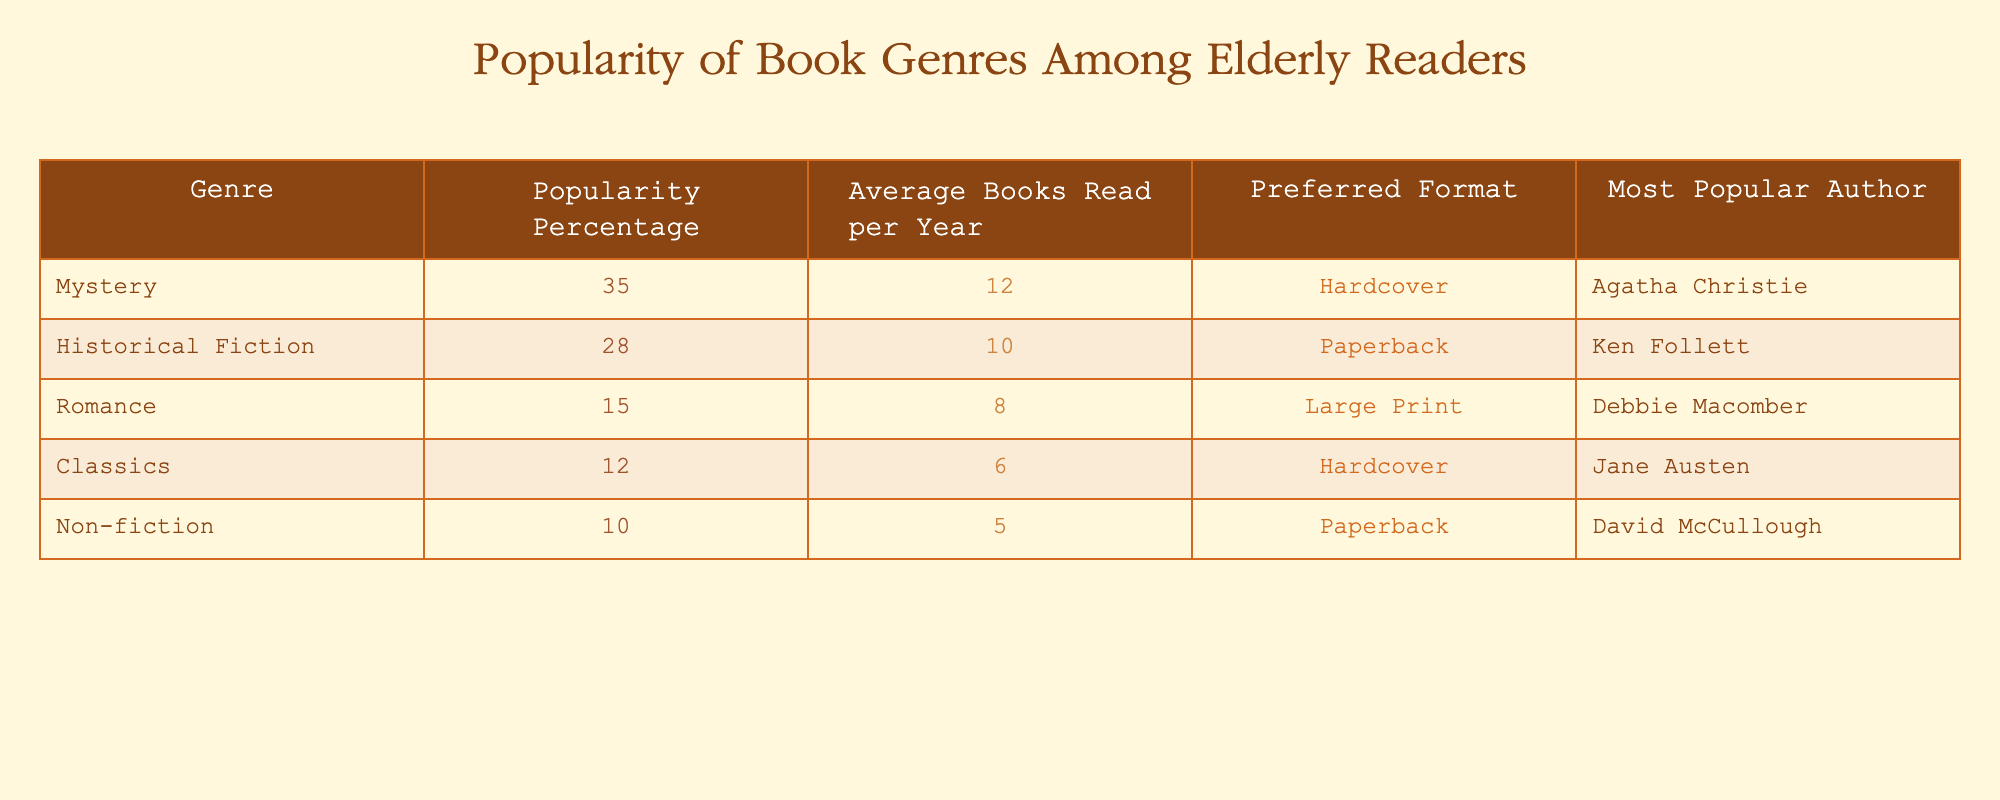What is the most popular book genre among elderly readers? The table shows that the genre with the highest popularity percentage is Mystery at 35%.
Answer: Mystery Which author is associated with the Historical Fiction genre? According to the table, the most popular author for Historical Fiction is Ken Follett.
Answer: Ken Follett How many average books does an elderly reader read in a year for the Romance genre? The table lists that elderly readers read an average of 8 books per year in the Romance genre.
Answer: 8 What percentage of elderly readers prefer Mystery over Non-fiction? The table indicates a popularity percentage of 35% for Mystery and 10% for Non-fiction. The difference is 35% - 10% = 25%.
Answer: 25% Is it true that the Classics genre has a higher popularity percentage than Non-fiction? The table shows that Classics has 12% popularity and Non-fiction has 10%. Since 12% is greater than 10%, the statement is true.
Answer: Yes If you add the average books read per year for Mystery and Historical Fiction, what do you get? The average books read per year for Mystery is 12 and for Historical Fiction is 10. Adding these together gives 12 + 10 = 22 books.
Answer: 22 Which genre has the least number of average books read per year? From the table, Non-fiction has the least average books read per year at 5.
Answer: Non-fiction How many genres have a popularity percentage of 15% or higher? The table lists five genres: Mystery (35%), Historical Fiction (28%), Romance (15%), Classics (12%), and Non-fiction (10%). Therefore, the genres with a popularity percentage of 15% or higher are Mystery, Historical Fiction, and Romance, totaling three genres.
Answer: 3 Who is the most popular author for the Classics genre? The table indicates that Jane Austen is the most popular author for the Classics genre.
Answer: Jane Austen 